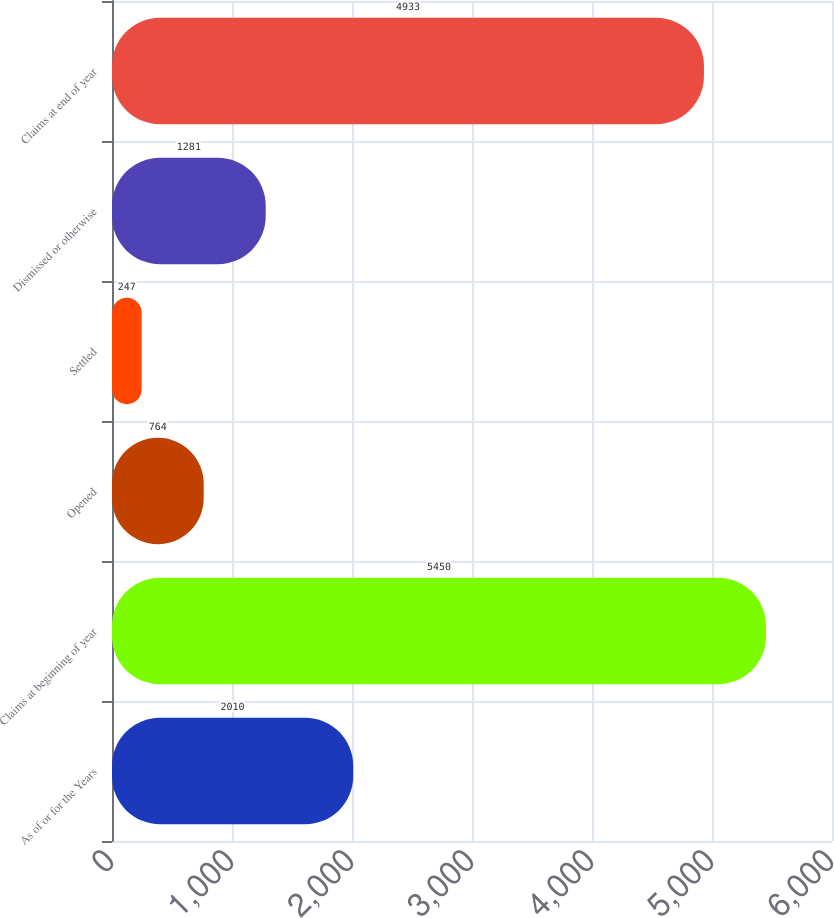<chart> <loc_0><loc_0><loc_500><loc_500><bar_chart><fcel>As of or for the Years<fcel>Claims at beginning of year<fcel>Opened<fcel>Settled<fcel>Dismissed or otherwise<fcel>Claims at end of year<nl><fcel>2010<fcel>5450<fcel>764<fcel>247<fcel>1281<fcel>4933<nl></chart> 